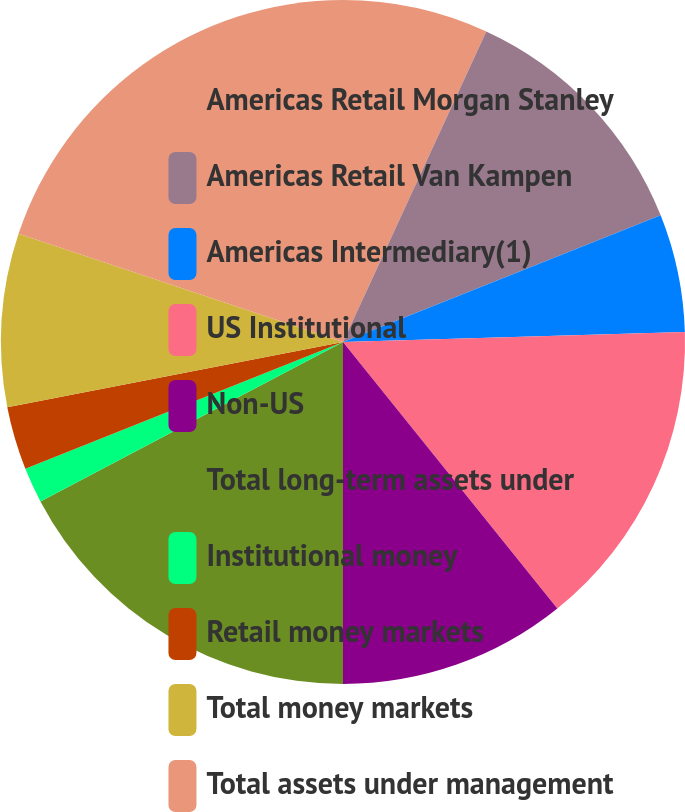<chart> <loc_0><loc_0><loc_500><loc_500><pie_chart><fcel>Americas Retail Morgan Stanley<fcel>Americas Retail Van Kampen<fcel>Americas Intermediary(1)<fcel>US Institutional<fcel>Non-US<fcel>Total long-term assets under<fcel>Institutional money<fcel>Retail money markets<fcel>Total money markets<fcel>Total assets under management<nl><fcel>6.88%<fcel>12.08%<fcel>5.58%<fcel>14.68%<fcel>10.78%<fcel>17.28%<fcel>1.68%<fcel>2.98%<fcel>8.18%<fcel>19.88%<nl></chart> 